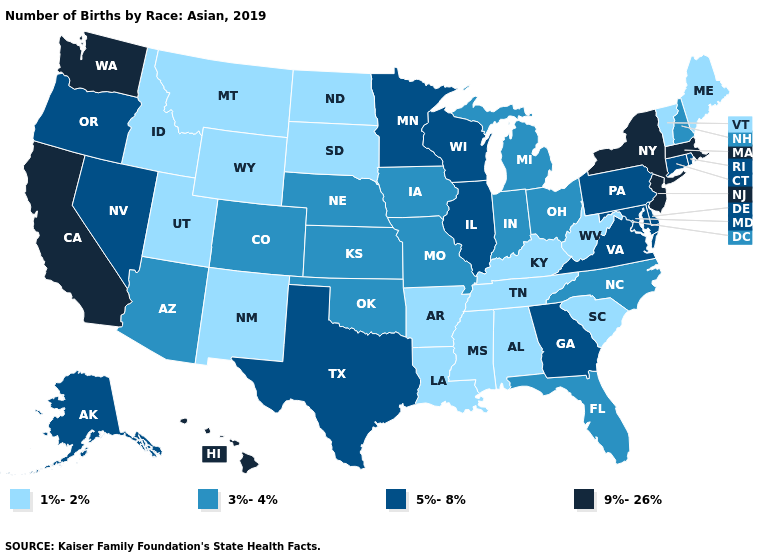Is the legend a continuous bar?
Give a very brief answer. No. Which states have the highest value in the USA?
Short answer required. California, Hawaii, Massachusetts, New Jersey, New York, Washington. Name the states that have a value in the range 9%-26%?
Keep it brief. California, Hawaii, Massachusetts, New Jersey, New York, Washington. Is the legend a continuous bar?
Short answer required. No. What is the highest value in the South ?
Concise answer only. 5%-8%. Name the states that have a value in the range 1%-2%?
Concise answer only. Alabama, Arkansas, Idaho, Kentucky, Louisiana, Maine, Mississippi, Montana, New Mexico, North Dakota, South Carolina, South Dakota, Tennessee, Utah, Vermont, West Virginia, Wyoming. Name the states that have a value in the range 1%-2%?
Be succinct. Alabama, Arkansas, Idaho, Kentucky, Louisiana, Maine, Mississippi, Montana, New Mexico, North Dakota, South Carolina, South Dakota, Tennessee, Utah, Vermont, West Virginia, Wyoming. Does the first symbol in the legend represent the smallest category?
Give a very brief answer. Yes. Name the states that have a value in the range 9%-26%?
Write a very short answer. California, Hawaii, Massachusetts, New Jersey, New York, Washington. What is the value of Vermont?
Write a very short answer. 1%-2%. What is the lowest value in states that border Louisiana?
Short answer required. 1%-2%. What is the value of Rhode Island?
Write a very short answer. 5%-8%. Name the states that have a value in the range 9%-26%?
Give a very brief answer. California, Hawaii, Massachusetts, New Jersey, New York, Washington. Name the states that have a value in the range 9%-26%?
Write a very short answer. California, Hawaii, Massachusetts, New Jersey, New York, Washington. 